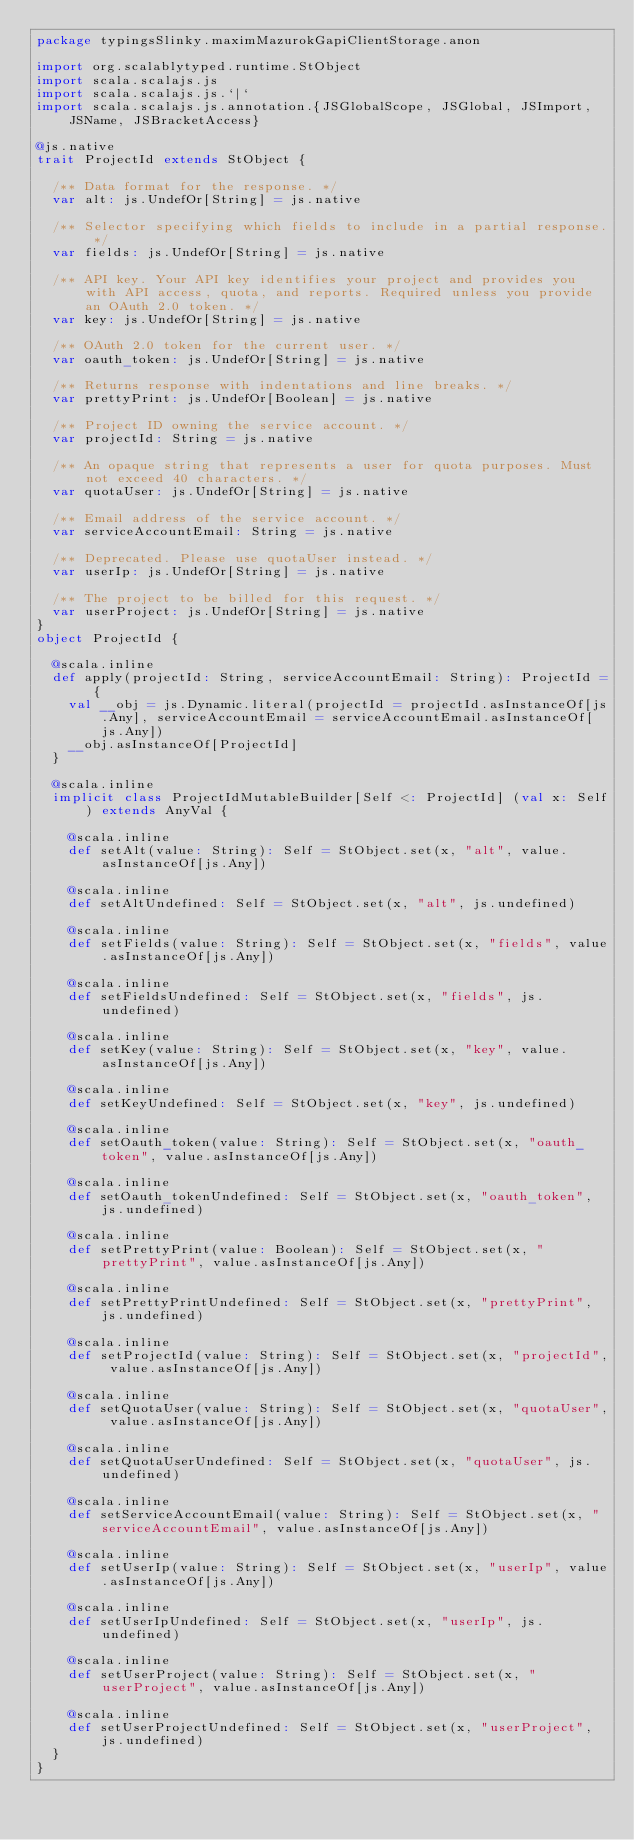<code> <loc_0><loc_0><loc_500><loc_500><_Scala_>package typingsSlinky.maximMazurokGapiClientStorage.anon

import org.scalablytyped.runtime.StObject
import scala.scalajs.js
import scala.scalajs.js.`|`
import scala.scalajs.js.annotation.{JSGlobalScope, JSGlobal, JSImport, JSName, JSBracketAccess}

@js.native
trait ProjectId extends StObject {
  
  /** Data format for the response. */
  var alt: js.UndefOr[String] = js.native
  
  /** Selector specifying which fields to include in a partial response. */
  var fields: js.UndefOr[String] = js.native
  
  /** API key. Your API key identifies your project and provides you with API access, quota, and reports. Required unless you provide an OAuth 2.0 token. */
  var key: js.UndefOr[String] = js.native
  
  /** OAuth 2.0 token for the current user. */
  var oauth_token: js.UndefOr[String] = js.native
  
  /** Returns response with indentations and line breaks. */
  var prettyPrint: js.UndefOr[Boolean] = js.native
  
  /** Project ID owning the service account. */
  var projectId: String = js.native
  
  /** An opaque string that represents a user for quota purposes. Must not exceed 40 characters. */
  var quotaUser: js.UndefOr[String] = js.native
  
  /** Email address of the service account. */
  var serviceAccountEmail: String = js.native
  
  /** Deprecated. Please use quotaUser instead. */
  var userIp: js.UndefOr[String] = js.native
  
  /** The project to be billed for this request. */
  var userProject: js.UndefOr[String] = js.native
}
object ProjectId {
  
  @scala.inline
  def apply(projectId: String, serviceAccountEmail: String): ProjectId = {
    val __obj = js.Dynamic.literal(projectId = projectId.asInstanceOf[js.Any], serviceAccountEmail = serviceAccountEmail.asInstanceOf[js.Any])
    __obj.asInstanceOf[ProjectId]
  }
  
  @scala.inline
  implicit class ProjectIdMutableBuilder[Self <: ProjectId] (val x: Self) extends AnyVal {
    
    @scala.inline
    def setAlt(value: String): Self = StObject.set(x, "alt", value.asInstanceOf[js.Any])
    
    @scala.inline
    def setAltUndefined: Self = StObject.set(x, "alt", js.undefined)
    
    @scala.inline
    def setFields(value: String): Self = StObject.set(x, "fields", value.asInstanceOf[js.Any])
    
    @scala.inline
    def setFieldsUndefined: Self = StObject.set(x, "fields", js.undefined)
    
    @scala.inline
    def setKey(value: String): Self = StObject.set(x, "key", value.asInstanceOf[js.Any])
    
    @scala.inline
    def setKeyUndefined: Self = StObject.set(x, "key", js.undefined)
    
    @scala.inline
    def setOauth_token(value: String): Self = StObject.set(x, "oauth_token", value.asInstanceOf[js.Any])
    
    @scala.inline
    def setOauth_tokenUndefined: Self = StObject.set(x, "oauth_token", js.undefined)
    
    @scala.inline
    def setPrettyPrint(value: Boolean): Self = StObject.set(x, "prettyPrint", value.asInstanceOf[js.Any])
    
    @scala.inline
    def setPrettyPrintUndefined: Self = StObject.set(x, "prettyPrint", js.undefined)
    
    @scala.inline
    def setProjectId(value: String): Self = StObject.set(x, "projectId", value.asInstanceOf[js.Any])
    
    @scala.inline
    def setQuotaUser(value: String): Self = StObject.set(x, "quotaUser", value.asInstanceOf[js.Any])
    
    @scala.inline
    def setQuotaUserUndefined: Self = StObject.set(x, "quotaUser", js.undefined)
    
    @scala.inline
    def setServiceAccountEmail(value: String): Self = StObject.set(x, "serviceAccountEmail", value.asInstanceOf[js.Any])
    
    @scala.inline
    def setUserIp(value: String): Self = StObject.set(x, "userIp", value.asInstanceOf[js.Any])
    
    @scala.inline
    def setUserIpUndefined: Self = StObject.set(x, "userIp", js.undefined)
    
    @scala.inline
    def setUserProject(value: String): Self = StObject.set(x, "userProject", value.asInstanceOf[js.Any])
    
    @scala.inline
    def setUserProjectUndefined: Self = StObject.set(x, "userProject", js.undefined)
  }
}
</code> 